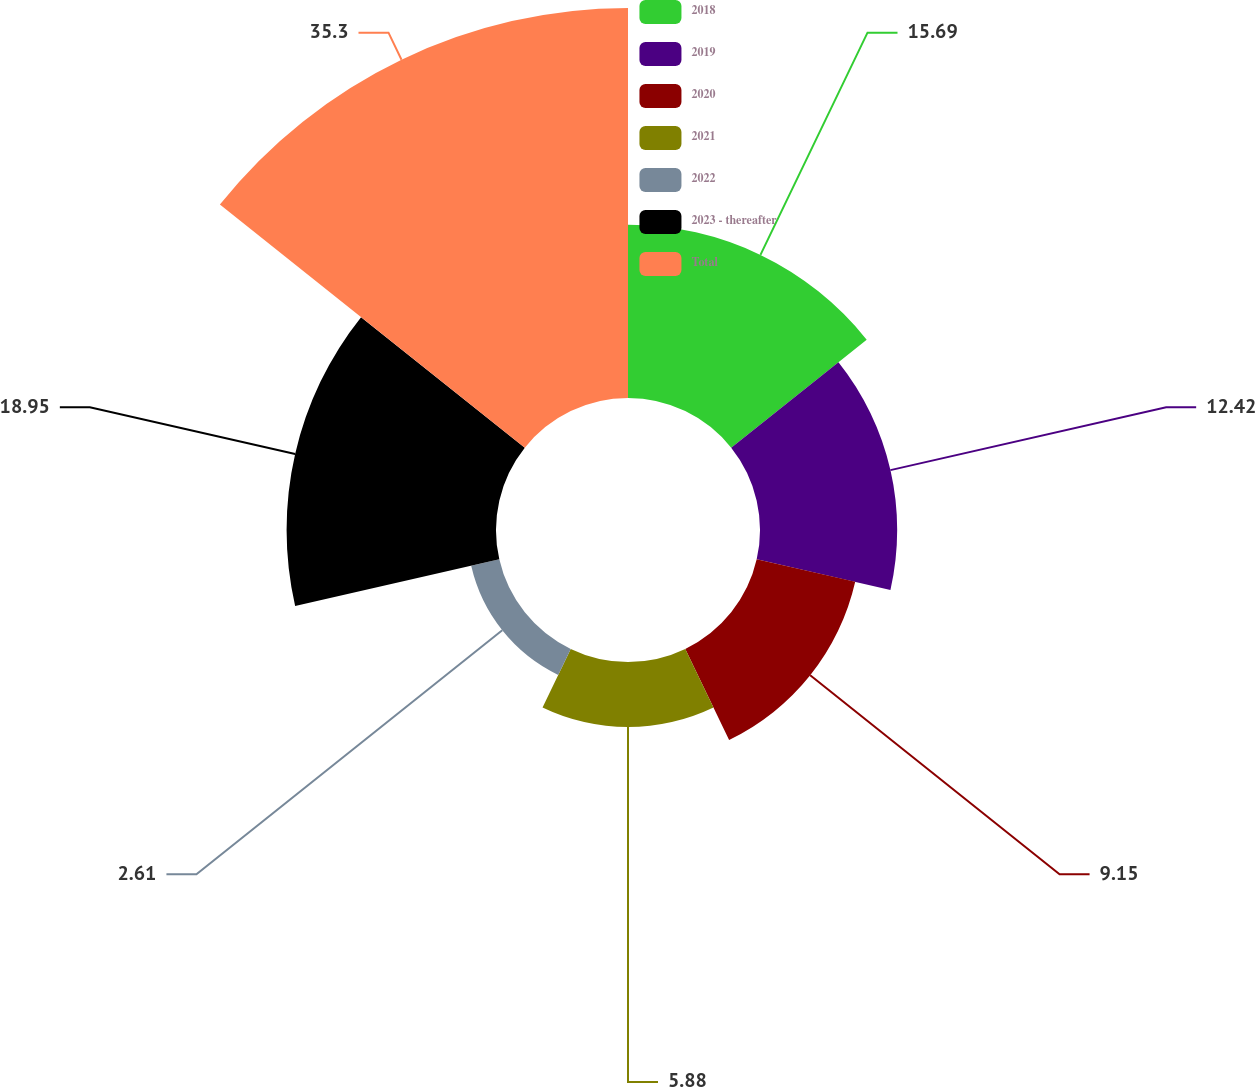Convert chart. <chart><loc_0><loc_0><loc_500><loc_500><pie_chart><fcel>2018<fcel>2019<fcel>2020<fcel>2021<fcel>2022<fcel>2023 - thereafter<fcel>Total<nl><fcel>15.69%<fcel>12.42%<fcel>9.15%<fcel>5.88%<fcel>2.61%<fcel>18.96%<fcel>35.31%<nl></chart> 